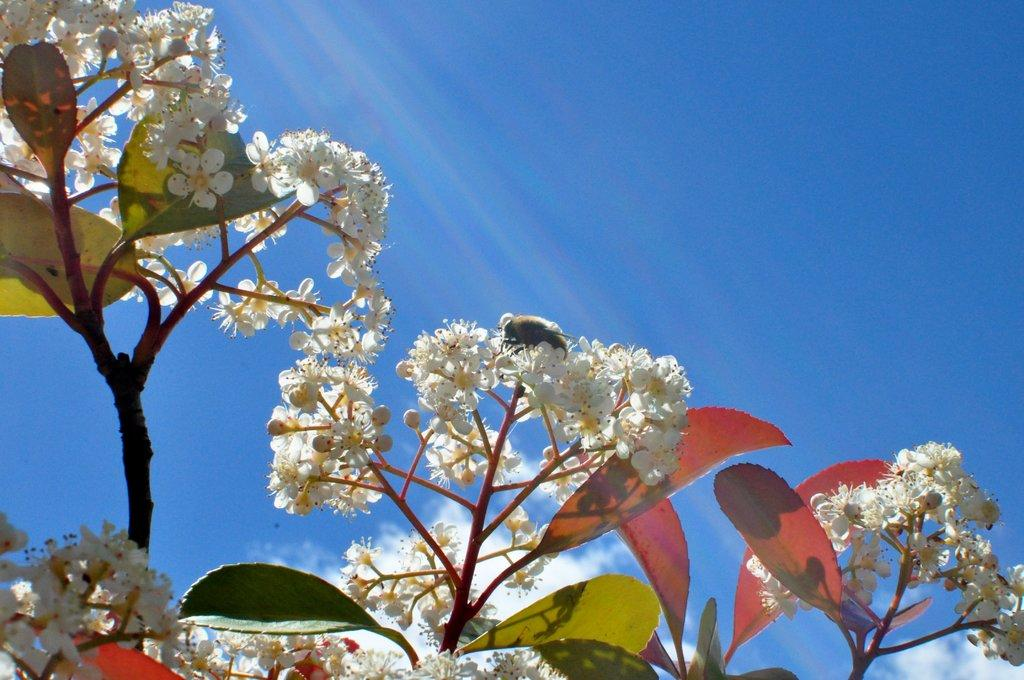What types of living organisms can be seen in the image? Plants and flowers are visible in the image. What can be seen in the background of the image? Clouds and the sky are visible in the background of the image. What type of bag is hanging from the tree in the image? There is no bag present in the image; it features plants and flowers with a background of clouds and the sky. 